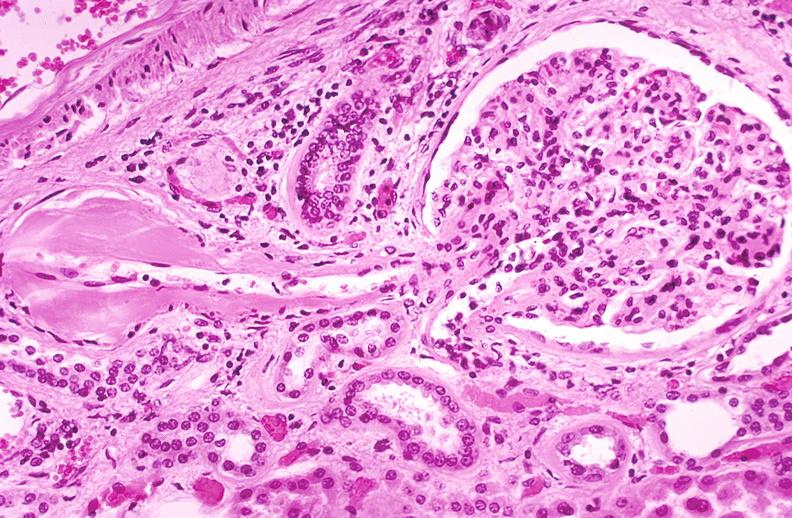does this image show kidney glomerulus, arteriolar thickening in a patient with diabetes mellitus?
Answer the question using a single word or phrase. Yes 